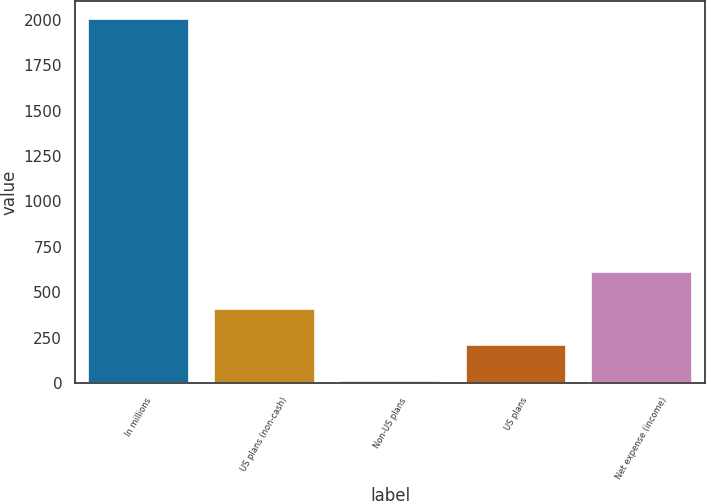Convert chart. <chart><loc_0><loc_0><loc_500><loc_500><bar_chart><fcel>In millions<fcel>US plans (non-cash)<fcel>Non-US plans<fcel>US plans<fcel>Net expense (income)<nl><fcel>2003<fcel>410.2<fcel>12<fcel>211.1<fcel>609.3<nl></chart> 